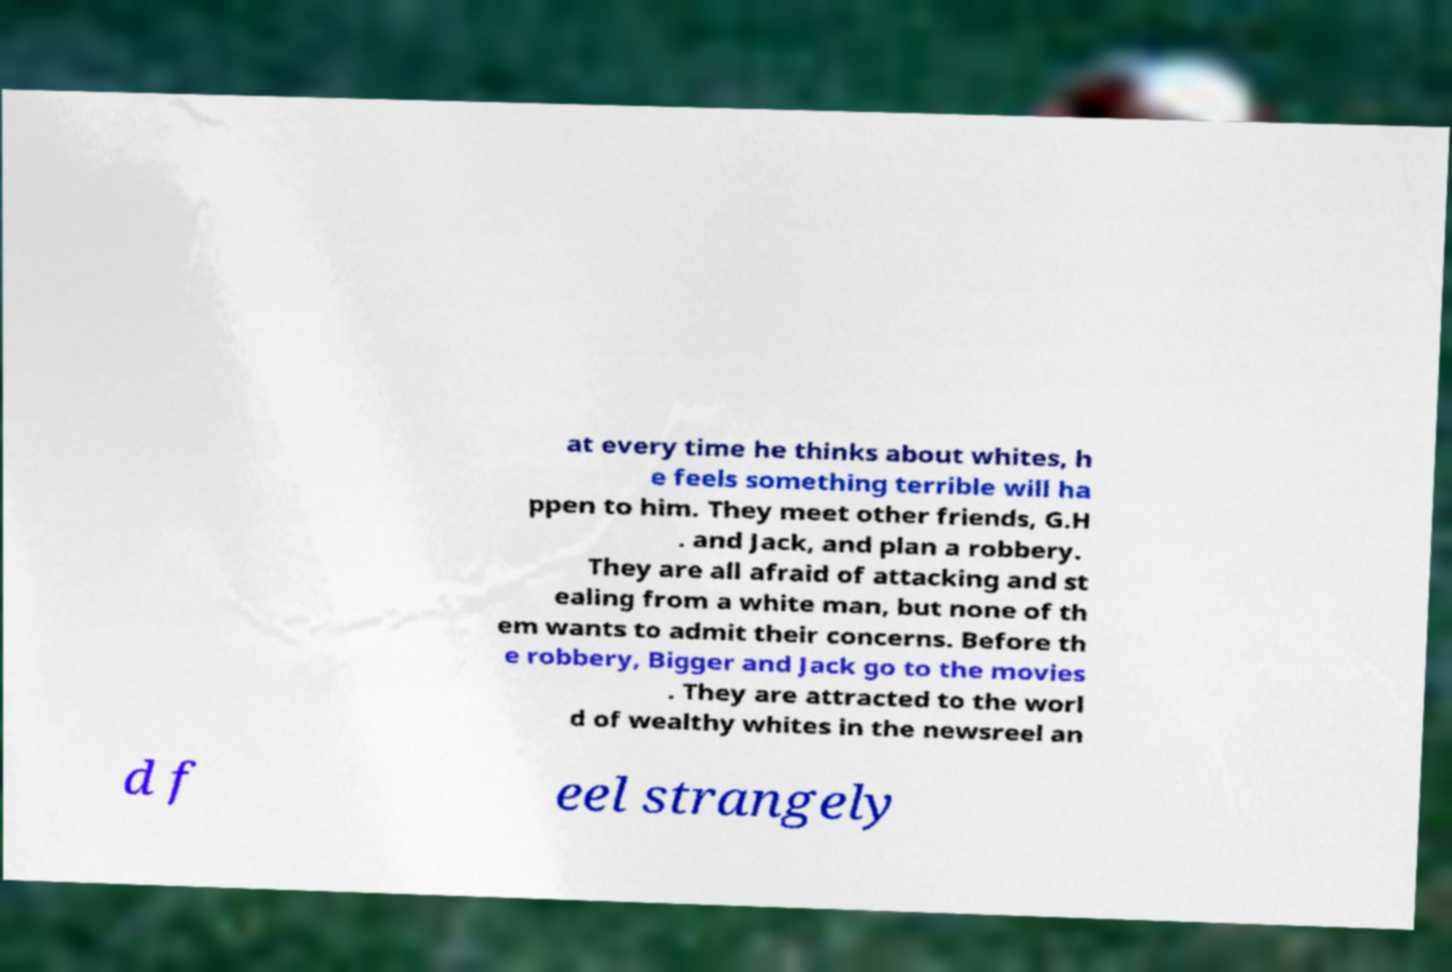Can you read and provide the text displayed in the image?This photo seems to have some interesting text. Can you extract and type it out for me? at every time he thinks about whites, h e feels something terrible will ha ppen to him. They meet other friends, G.H . and Jack, and plan a robbery. They are all afraid of attacking and st ealing from a white man, but none of th em wants to admit their concerns. Before th e robbery, Bigger and Jack go to the movies . They are attracted to the worl d of wealthy whites in the newsreel an d f eel strangely 